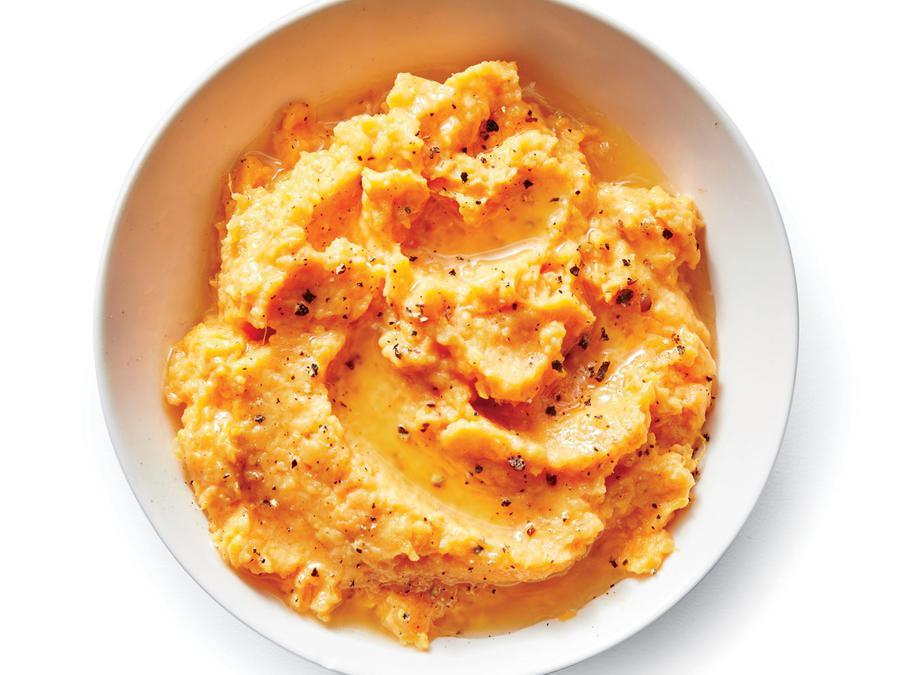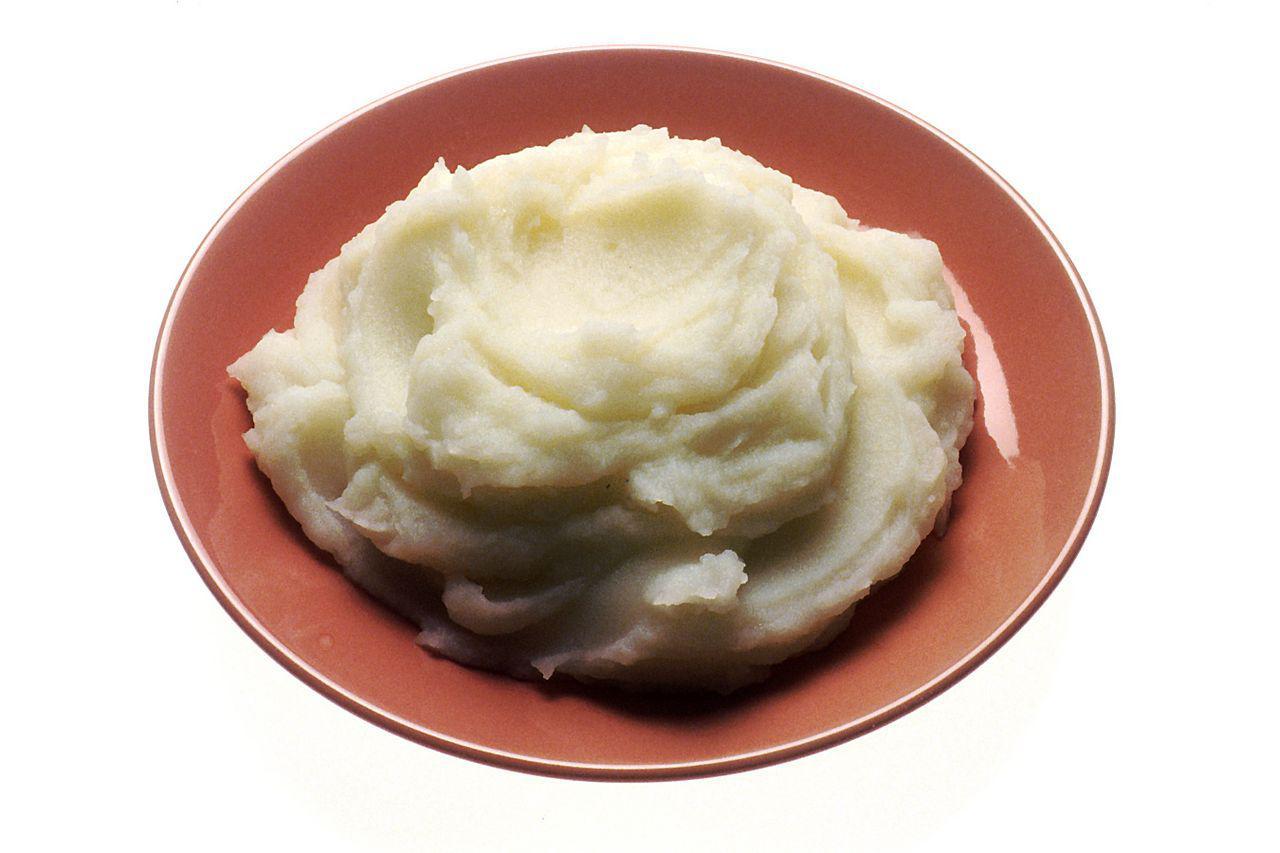The first image is the image on the left, the second image is the image on the right. Considering the images on both sides, is "A dish includes meatloaf topped with mashed potatoes and brown gravy." valid? Answer yes or no. No. The first image is the image on the left, the second image is the image on the right. Analyze the images presented: Is the assertion "There is nothing on top of a mashed potato in the right image." valid? Answer yes or no. Yes. 